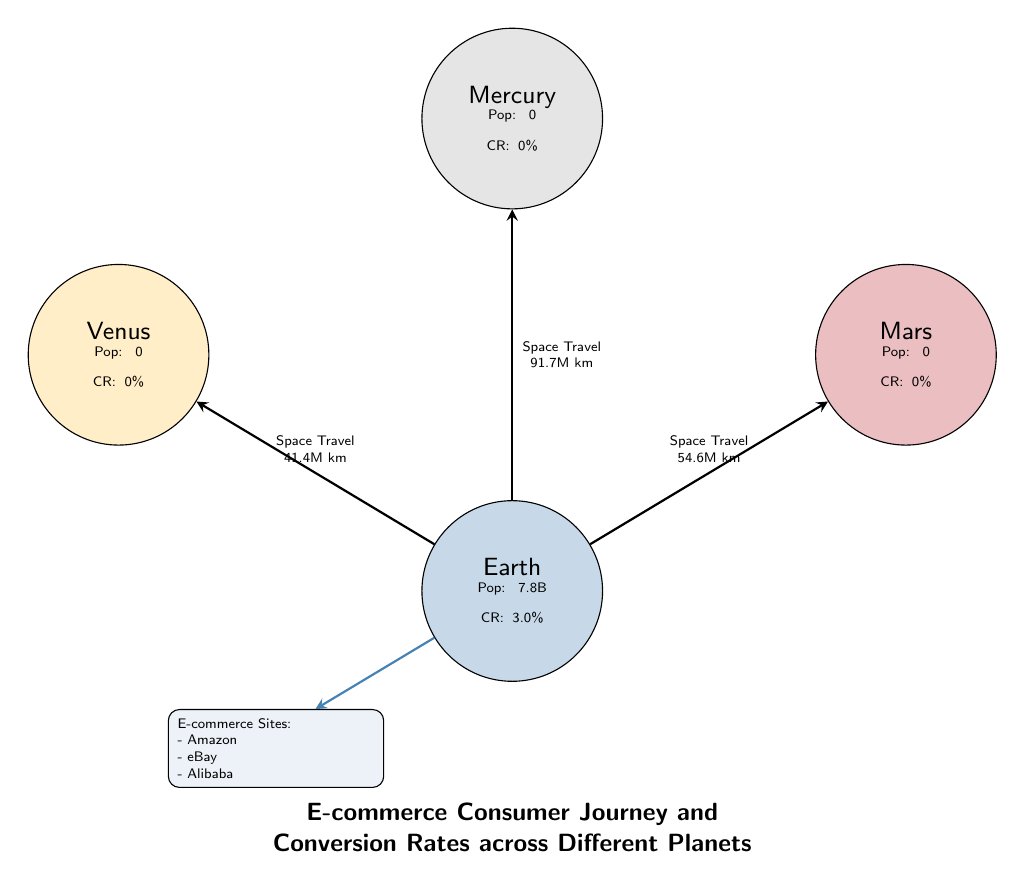What is the conversion rate for Earth? The diagram shows a single piece of information for Earth regarding conversion rates, specifically stating "CR: 3.0%".
Answer: 3.0% How many planets are shown in the diagram? The diagram features four planets: Earth, Mars, Venus, and Mercury. By counting them, we identify there are four planets.
Answer: 4 What is the distance from Earth to Mars? The link connecting Earth and Mars is labeled "Space Travel 54.6M km", indicating the distance between these two planets.
Answer: 54.6M km What is the population of Mars? The diagram displays that Mars has a population of 0 (indicated as "Pop: 0"). Therefore, the population of Mars is 0.
Answer: 0 Which planet has the highest conversion rate? The only planet with a conversion rate mentioned is Earth, which has a CR of 3.0%, while Mars, Venus, and Mercury have a CR of 0%. Thus, Earth has the highest conversion rate.
Answer: Earth How many e-commerce sites are listed in the diagram? The diagram includes a box that states "E-commerce Sites:" followed by three specific sites: Amazon, eBay, and Alibaba. Therefore, the number of e-commerce sites listed is three.
Answer: 3 What color represents Venus in the diagram? The diagram shows that Venus is filled with a yellow shade defined as "fill=venusyellow!30." Therefore, the color representing Venus is yellow.
Answer: yellow What type of diagram is this? The introduction provided in the diagram states "E-commerce Consumer Journey and Conversion Rates across Different Planets," indicating its focus. Therefore, this is an Astronomy Diagram.
Answer: Astronomy Diagram What is the population for Earth? Referring to the specific node for Earth, it states "Pop: 7.8B," indicating Earth's population.
Answer: 7.8B 